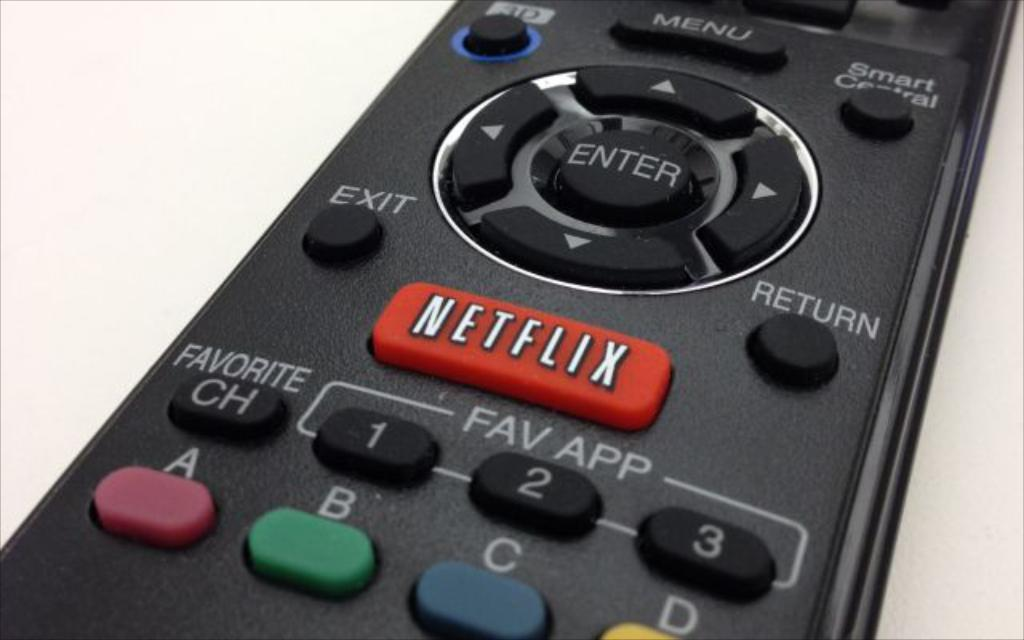<image>
Share a concise interpretation of the image provided. A remote control with a Netflix button under the Enter and directional buttons. 